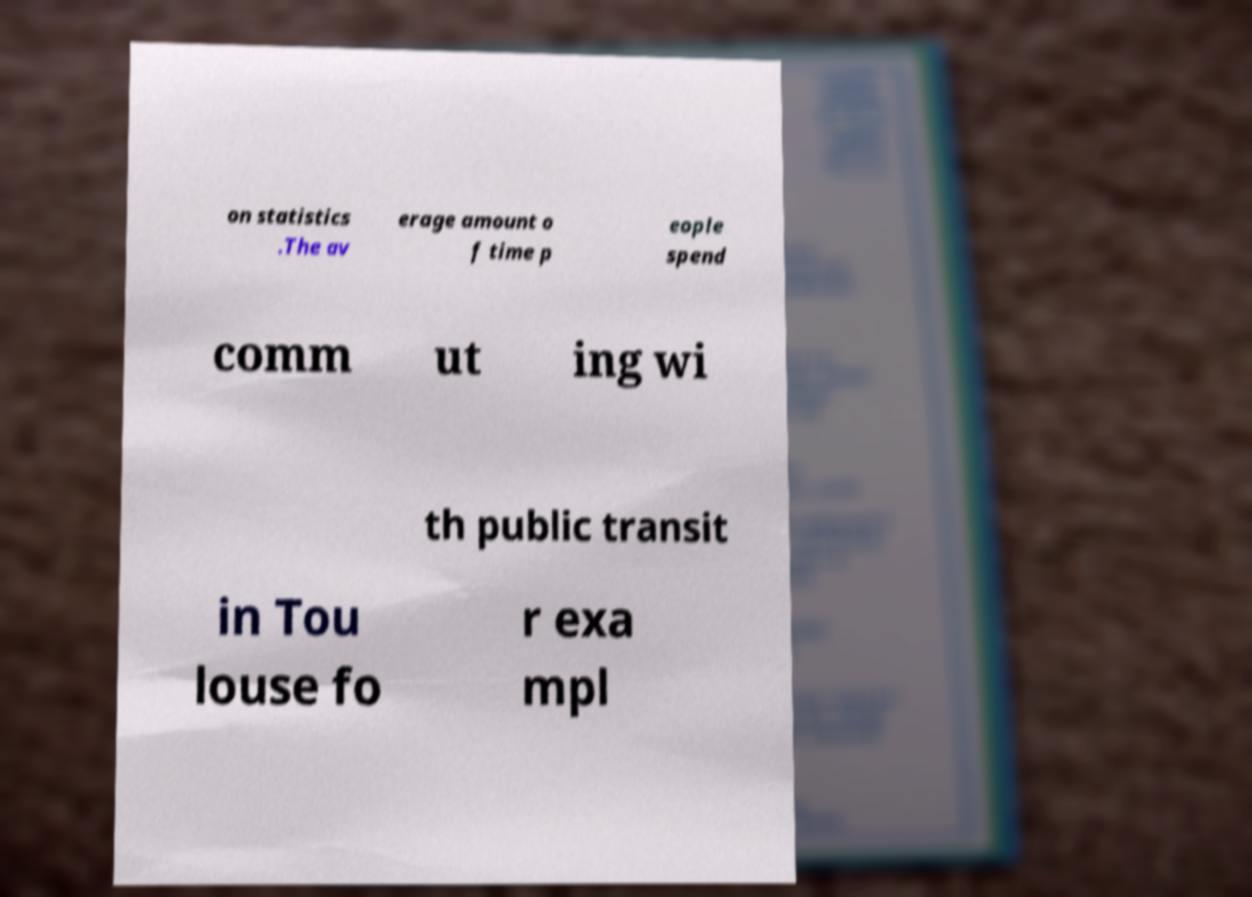I need the written content from this picture converted into text. Can you do that? on statistics .The av erage amount o f time p eople spend comm ut ing wi th public transit in Tou louse fo r exa mpl 